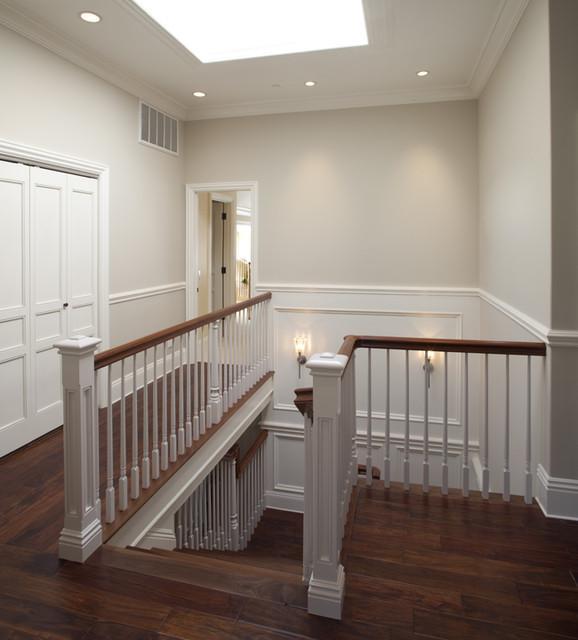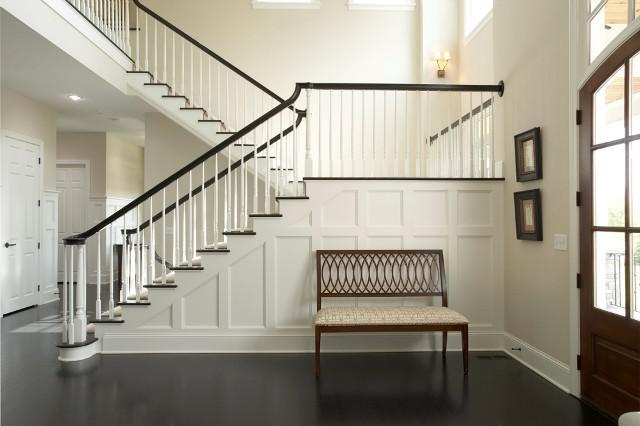The first image is the image on the left, the second image is the image on the right. Considering the images on both sides, is "The right image shows a staircase enclosed by white baseboard, with a dark handrail and white spindles, and the staircase ascends to a landing before turning directions." valid? Answer yes or no. Yes. 